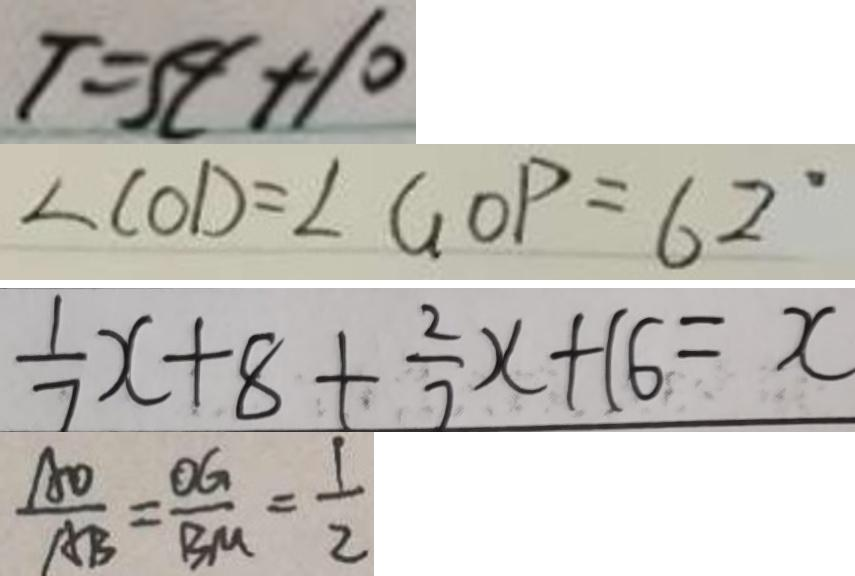<formula> <loc_0><loc_0><loc_500><loc_500>T = 5 t + 1 0 
 \angle C O D = \angle G O P = 6 2 ^ { \circ } 
 \frac { 1 } { 7 } x + 8 + \frac { 2 } { 7 } x + 1 6 = x 
 \frac { A O } { A B } = \frac { O G } { B M } = \frac { 1 } { 2 }</formula> 